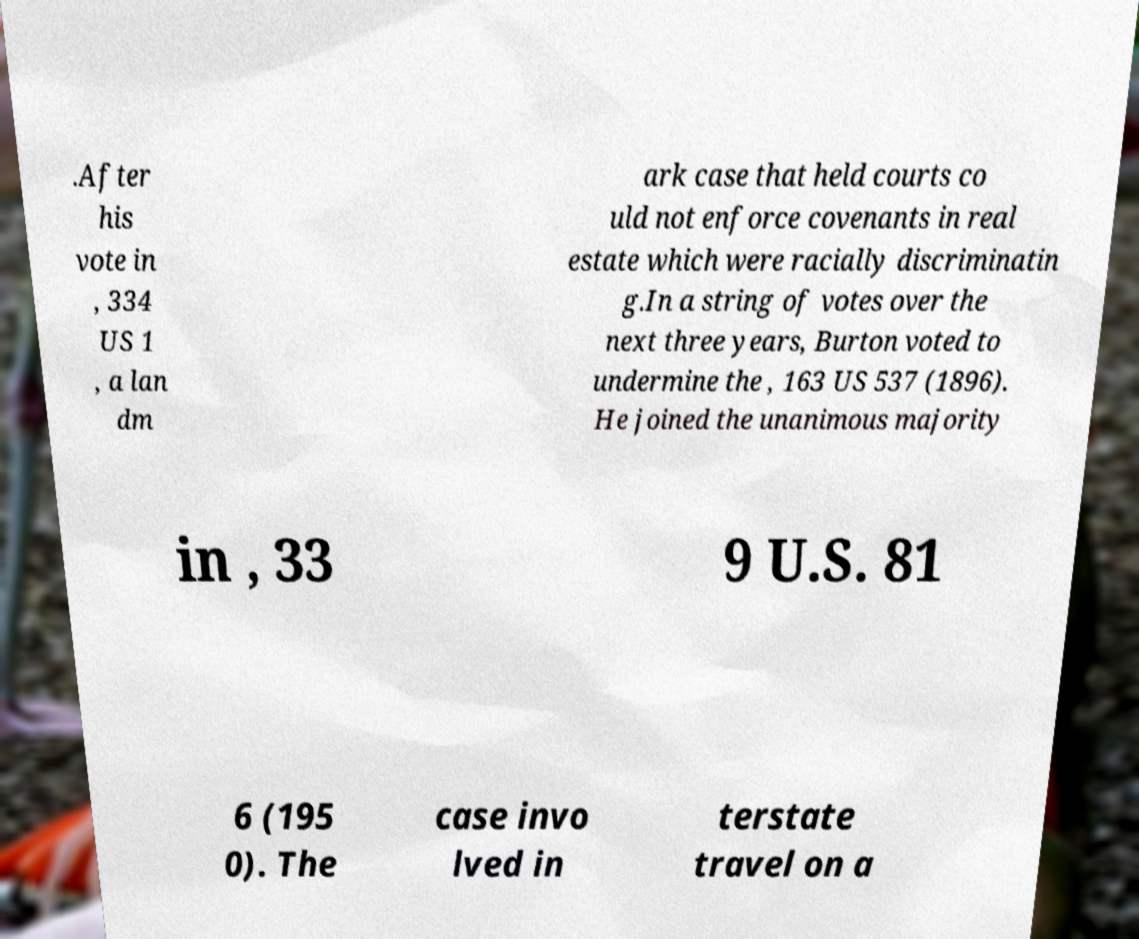Could you extract and type out the text from this image? .After his vote in , 334 US 1 , a lan dm ark case that held courts co uld not enforce covenants in real estate which were racially discriminatin g.In a string of votes over the next three years, Burton voted to undermine the , 163 US 537 (1896). He joined the unanimous majority in , 33 9 U.S. 81 6 (195 0). The case invo lved in terstate travel on a 